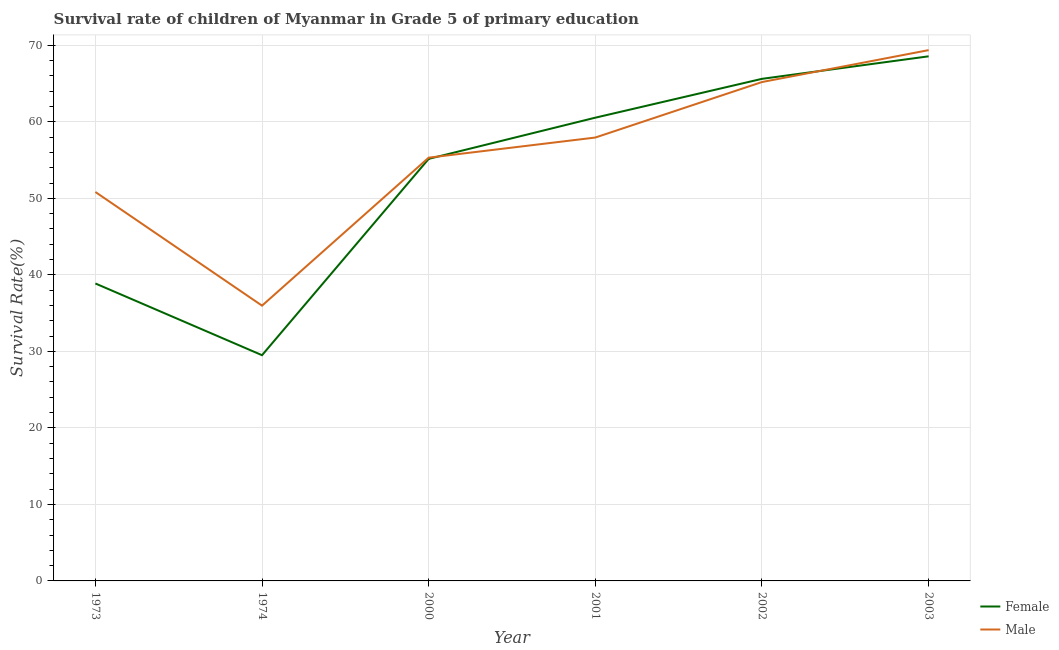How many different coloured lines are there?
Make the answer very short. 2. Does the line corresponding to survival rate of male students in primary education intersect with the line corresponding to survival rate of female students in primary education?
Provide a short and direct response. Yes. Is the number of lines equal to the number of legend labels?
Give a very brief answer. Yes. What is the survival rate of male students in primary education in 2002?
Offer a very short reply. 65.2. Across all years, what is the maximum survival rate of male students in primary education?
Provide a short and direct response. 69.37. Across all years, what is the minimum survival rate of male students in primary education?
Your response must be concise. 35.97. In which year was the survival rate of male students in primary education maximum?
Your answer should be compact. 2003. In which year was the survival rate of female students in primary education minimum?
Keep it short and to the point. 1974. What is the total survival rate of female students in primary education in the graph?
Keep it short and to the point. 318.24. What is the difference between the survival rate of female students in primary education in 1974 and that in 2001?
Your answer should be compact. -31.04. What is the difference between the survival rate of male students in primary education in 2003 and the survival rate of female students in primary education in 2002?
Give a very brief answer. 3.75. What is the average survival rate of male students in primary education per year?
Provide a short and direct response. 55.77. In the year 1974, what is the difference between the survival rate of female students in primary education and survival rate of male students in primary education?
Ensure brevity in your answer.  -6.47. In how many years, is the survival rate of female students in primary education greater than 50 %?
Offer a terse response. 4. What is the ratio of the survival rate of female students in primary education in 2002 to that in 2003?
Offer a terse response. 0.96. Is the difference between the survival rate of male students in primary education in 1973 and 2002 greater than the difference between the survival rate of female students in primary education in 1973 and 2002?
Provide a short and direct response. Yes. What is the difference between the highest and the second highest survival rate of female students in primary education?
Your response must be concise. 2.94. What is the difference between the highest and the lowest survival rate of female students in primary education?
Give a very brief answer. 39.06. Is the sum of the survival rate of female students in primary education in 1973 and 2000 greater than the maximum survival rate of male students in primary education across all years?
Give a very brief answer. Yes. Is the survival rate of male students in primary education strictly greater than the survival rate of female students in primary education over the years?
Give a very brief answer. No. Is the survival rate of female students in primary education strictly less than the survival rate of male students in primary education over the years?
Your response must be concise. No. Does the graph contain grids?
Provide a succinct answer. Yes. Where does the legend appear in the graph?
Your answer should be very brief. Bottom right. How many legend labels are there?
Provide a succinct answer. 2. How are the legend labels stacked?
Keep it short and to the point. Vertical. What is the title of the graph?
Ensure brevity in your answer.  Survival rate of children of Myanmar in Grade 5 of primary education. Does "Resident workers" appear as one of the legend labels in the graph?
Provide a succinct answer. No. What is the label or title of the Y-axis?
Provide a short and direct response. Survival Rate(%). What is the Survival Rate(%) of Female in 1973?
Your answer should be very brief. 38.87. What is the Survival Rate(%) of Male in 1973?
Provide a short and direct response. 50.83. What is the Survival Rate(%) in Female in 1974?
Your answer should be compact. 29.5. What is the Survival Rate(%) in Male in 1974?
Ensure brevity in your answer.  35.97. What is the Survival Rate(%) in Female in 2000?
Offer a very short reply. 55.16. What is the Survival Rate(%) of Male in 2000?
Your answer should be compact. 55.31. What is the Survival Rate(%) of Female in 2001?
Your response must be concise. 60.54. What is the Survival Rate(%) in Male in 2001?
Provide a succinct answer. 57.94. What is the Survival Rate(%) of Female in 2002?
Your answer should be very brief. 65.61. What is the Survival Rate(%) of Male in 2002?
Provide a succinct answer. 65.2. What is the Survival Rate(%) in Female in 2003?
Offer a very short reply. 68.56. What is the Survival Rate(%) in Male in 2003?
Make the answer very short. 69.37. Across all years, what is the maximum Survival Rate(%) in Female?
Your response must be concise. 68.56. Across all years, what is the maximum Survival Rate(%) in Male?
Make the answer very short. 69.37. Across all years, what is the minimum Survival Rate(%) of Female?
Ensure brevity in your answer.  29.5. Across all years, what is the minimum Survival Rate(%) in Male?
Provide a short and direct response. 35.97. What is the total Survival Rate(%) in Female in the graph?
Your answer should be very brief. 318.24. What is the total Survival Rate(%) in Male in the graph?
Give a very brief answer. 334.62. What is the difference between the Survival Rate(%) of Female in 1973 and that in 1974?
Your answer should be very brief. 9.37. What is the difference between the Survival Rate(%) of Male in 1973 and that in 1974?
Keep it short and to the point. 14.86. What is the difference between the Survival Rate(%) in Female in 1973 and that in 2000?
Provide a succinct answer. -16.28. What is the difference between the Survival Rate(%) in Male in 1973 and that in 2000?
Keep it short and to the point. -4.48. What is the difference between the Survival Rate(%) in Female in 1973 and that in 2001?
Give a very brief answer. -21.67. What is the difference between the Survival Rate(%) in Male in 1973 and that in 2001?
Offer a terse response. -7.12. What is the difference between the Survival Rate(%) in Female in 1973 and that in 2002?
Offer a very short reply. -26.74. What is the difference between the Survival Rate(%) of Male in 1973 and that in 2002?
Ensure brevity in your answer.  -14.37. What is the difference between the Survival Rate(%) of Female in 1973 and that in 2003?
Keep it short and to the point. -29.69. What is the difference between the Survival Rate(%) in Male in 1973 and that in 2003?
Offer a terse response. -18.54. What is the difference between the Survival Rate(%) in Female in 1974 and that in 2000?
Ensure brevity in your answer.  -25.66. What is the difference between the Survival Rate(%) in Male in 1974 and that in 2000?
Your response must be concise. -19.34. What is the difference between the Survival Rate(%) in Female in 1974 and that in 2001?
Give a very brief answer. -31.04. What is the difference between the Survival Rate(%) of Male in 1974 and that in 2001?
Make the answer very short. -21.97. What is the difference between the Survival Rate(%) in Female in 1974 and that in 2002?
Give a very brief answer. -36.12. What is the difference between the Survival Rate(%) in Male in 1974 and that in 2002?
Give a very brief answer. -29.22. What is the difference between the Survival Rate(%) of Female in 1974 and that in 2003?
Make the answer very short. -39.06. What is the difference between the Survival Rate(%) of Male in 1974 and that in 2003?
Provide a short and direct response. -33.39. What is the difference between the Survival Rate(%) in Female in 2000 and that in 2001?
Keep it short and to the point. -5.38. What is the difference between the Survival Rate(%) in Male in 2000 and that in 2001?
Provide a succinct answer. -2.63. What is the difference between the Survival Rate(%) in Female in 2000 and that in 2002?
Offer a very short reply. -10.46. What is the difference between the Survival Rate(%) in Male in 2000 and that in 2002?
Give a very brief answer. -9.88. What is the difference between the Survival Rate(%) in Female in 2000 and that in 2003?
Offer a terse response. -13.4. What is the difference between the Survival Rate(%) in Male in 2000 and that in 2003?
Provide a short and direct response. -14.05. What is the difference between the Survival Rate(%) of Female in 2001 and that in 2002?
Your answer should be compact. -5.08. What is the difference between the Survival Rate(%) in Male in 2001 and that in 2002?
Offer a very short reply. -7.25. What is the difference between the Survival Rate(%) of Female in 2001 and that in 2003?
Ensure brevity in your answer.  -8.02. What is the difference between the Survival Rate(%) in Male in 2001 and that in 2003?
Offer a very short reply. -11.42. What is the difference between the Survival Rate(%) in Female in 2002 and that in 2003?
Offer a very short reply. -2.94. What is the difference between the Survival Rate(%) of Male in 2002 and that in 2003?
Keep it short and to the point. -4.17. What is the difference between the Survival Rate(%) of Female in 1973 and the Survival Rate(%) of Male in 1974?
Provide a short and direct response. 2.9. What is the difference between the Survival Rate(%) of Female in 1973 and the Survival Rate(%) of Male in 2000?
Keep it short and to the point. -16.44. What is the difference between the Survival Rate(%) in Female in 1973 and the Survival Rate(%) in Male in 2001?
Provide a succinct answer. -19.07. What is the difference between the Survival Rate(%) in Female in 1973 and the Survival Rate(%) in Male in 2002?
Provide a short and direct response. -26.32. What is the difference between the Survival Rate(%) in Female in 1973 and the Survival Rate(%) in Male in 2003?
Keep it short and to the point. -30.49. What is the difference between the Survival Rate(%) of Female in 1974 and the Survival Rate(%) of Male in 2000?
Ensure brevity in your answer.  -25.81. What is the difference between the Survival Rate(%) in Female in 1974 and the Survival Rate(%) in Male in 2001?
Your response must be concise. -28.44. What is the difference between the Survival Rate(%) of Female in 1974 and the Survival Rate(%) of Male in 2002?
Your response must be concise. -35.7. What is the difference between the Survival Rate(%) of Female in 1974 and the Survival Rate(%) of Male in 2003?
Offer a very short reply. -39.87. What is the difference between the Survival Rate(%) of Female in 2000 and the Survival Rate(%) of Male in 2001?
Give a very brief answer. -2.79. What is the difference between the Survival Rate(%) in Female in 2000 and the Survival Rate(%) in Male in 2002?
Offer a terse response. -10.04. What is the difference between the Survival Rate(%) in Female in 2000 and the Survival Rate(%) in Male in 2003?
Ensure brevity in your answer.  -14.21. What is the difference between the Survival Rate(%) in Female in 2001 and the Survival Rate(%) in Male in 2002?
Offer a terse response. -4.66. What is the difference between the Survival Rate(%) of Female in 2001 and the Survival Rate(%) of Male in 2003?
Provide a succinct answer. -8.83. What is the difference between the Survival Rate(%) of Female in 2002 and the Survival Rate(%) of Male in 2003?
Make the answer very short. -3.75. What is the average Survival Rate(%) in Female per year?
Provide a short and direct response. 53.04. What is the average Survival Rate(%) of Male per year?
Your answer should be very brief. 55.77. In the year 1973, what is the difference between the Survival Rate(%) of Female and Survival Rate(%) of Male?
Provide a succinct answer. -11.96. In the year 1974, what is the difference between the Survival Rate(%) in Female and Survival Rate(%) in Male?
Keep it short and to the point. -6.47. In the year 2000, what is the difference between the Survival Rate(%) in Female and Survival Rate(%) in Male?
Offer a very short reply. -0.16. In the year 2001, what is the difference between the Survival Rate(%) of Female and Survival Rate(%) of Male?
Give a very brief answer. 2.6. In the year 2002, what is the difference between the Survival Rate(%) in Female and Survival Rate(%) in Male?
Your answer should be compact. 0.42. In the year 2003, what is the difference between the Survival Rate(%) of Female and Survival Rate(%) of Male?
Offer a terse response. -0.81. What is the ratio of the Survival Rate(%) of Female in 1973 to that in 1974?
Make the answer very short. 1.32. What is the ratio of the Survival Rate(%) of Male in 1973 to that in 1974?
Your answer should be very brief. 1.41. What is the ratio of the Survival Rate(%) in Female in 1973 to that in 2000?
Ensure brevity in your answer.  0.7. What is the ratio of the Survival Rate(%) in Male in 1973 to that in 2000?
Give a very brief answer. 0.92. What is the ratio of the Survival Rate(%) of Female in 1973 to that in 2001?
Provide a succinct answer. 0.64. What is the ratio of the Survival Rate(%) of Male in 1973 to that in 2001?
Your answer should be very brief. 0.88. What is the ratio of the Survival Rate(%) in Female in 1973 to that in 2002?
Offer a terse response. 0.59. What is the ratio of the Survival Rate(%) in Male in 1973 to that in 2002?
Keep it short and to the point. 0.78. What is the ratio of the Survival Rate(%) of Female in 1973 to that in 2003?
Provide a succinct answer. 0.57. What is the ratio of the Survival Rate(%) in Male in 1973 to that in 2003?
Ensure brevity in your answer.  0.73. What is the ratio of the Survival Rate(%) in Female in 1974 to that in 2000?
Your answer should be compact. 0.53. What is the ratio of the Survival Rate(%) of Male in 1974 to that in 2000?
Provide a short and direct response. 0.65. What is the ratio of the Survival Rate(%) in Female in 1974 to that in 2001?
Ensure brevity in your answer.  0.49. What is the ratio of the Survival Rate(%) of Male in 1974 to that in 2001?
Provide a short and direct response. 0.62. What is the ratio of the Survival Rate(%) of Female in 1974 to that in 2002?
Your response must be concise. 0.45. What is the ratio of the Survival Rate(%) in Male in 1974 to that in 2002?
Your response must be concise. 0.55. What is the ratio of the Survival Rate(%) of Female in 1974 to that in 2003?
Offer a very short reply. 0.43. What is the ratio of the Survival Rate(%) in Male in 1974 to that in 2003?
Give a very brief answer. 0.52. What is the ratio of the Survival Rate(%) of Female in 2000 to that in 2001?
Offer a very short reply. 0.91. What is the ratio of the Survival Rate(%) in Male in 2000 to that in 2001?
Provide a succinct answer. 0.95. What is the ratio of the Survival Rate(%) in Female in 2000 to that in 2002?
Keep it short and to the point. 0.84. What is the ratio of the Survival Rate(%) of Male in 2000 to that in 2002?
Keep it short and to the point. 0.85. What is the ratio of the Survival Rate(%) in Female in 2000 to that in 2003?
Your response must be concise. 0.8. What is the ratio of the Survival Rate(%) of Male in 2000 to that in 2003?
Keep it short and to the point. 0.8. What is the ratio of the Survival Rate(%) in Female in 2001 to that in 2002?
Keep it short and to the point. 0.92. What is the ratio of the Survival Rate(%) in Male in 2001 to that in 2002?
Offer a very short reply. 0.89. What is the ratio of the Survival Rate(%) of Female in 2001 to that in 2003?
Keep it short and to the point. 0.88. What is the ratio of the Survival Rate(%) of Male in 2001 to that in 2003?
Provide a succinct answer. 0.84. What is the ratio of the Survival Rate(%) in Female in 2002 to that in 2003?
Provide a succinct answer. 0.96. What is the ratio of the Survival Rate(%) in Male in 2002 to that in 2003?
Provide a short and direct response. 0.94. What is the difference between the highest and the second highest Survival Rate(%) in Female?
Offer a terse response. 2.94. What is the difference between the highest and the second highest Survival Rate(%) of Male?
Your answer should be very brief. 4.17. What is the difference between the highest and the lowest Survival Rate(%) of Female?
Make the answer very short. 39.06. What is the difference between the highest and the lowest Survival Rate(%) in Male?
Ensure brevity in your answer.  33.39. 